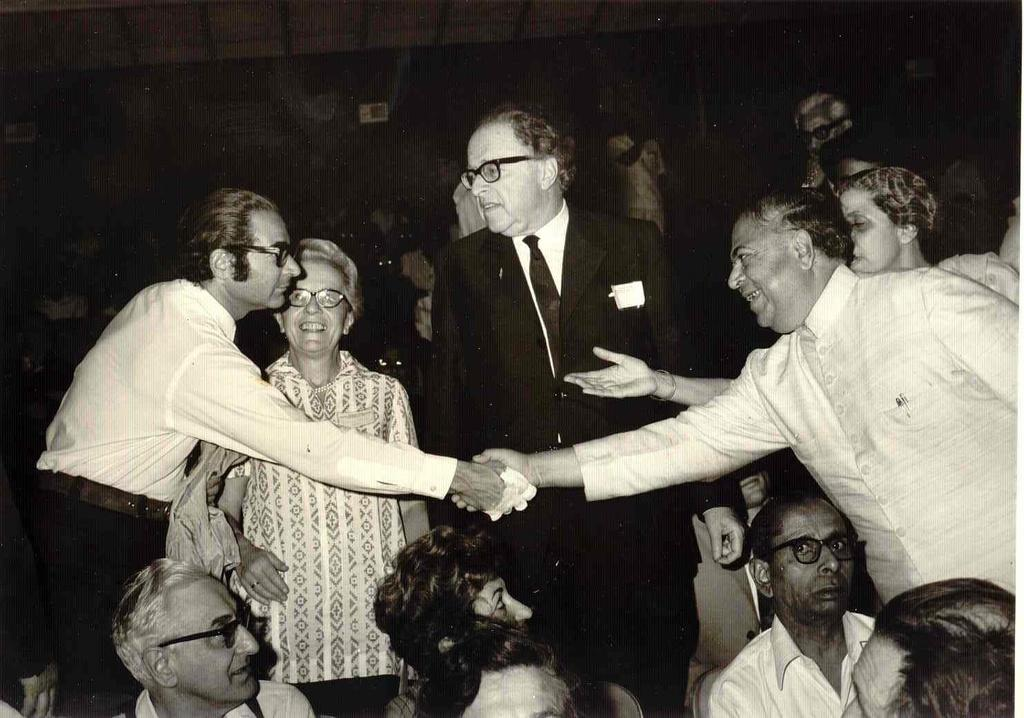What type of picture is in the image? The image contains a black and white picture. Can you describe the subjects in the picture? There is a group of people in the picture. What are some of the people in the picture doing? Some people are standing, and some people are sitting on chairs in the picture. What type of net can be seen in the aftermath of the event in the image? There is no net or event present in the image; it features a black and white picture of a group of people. 